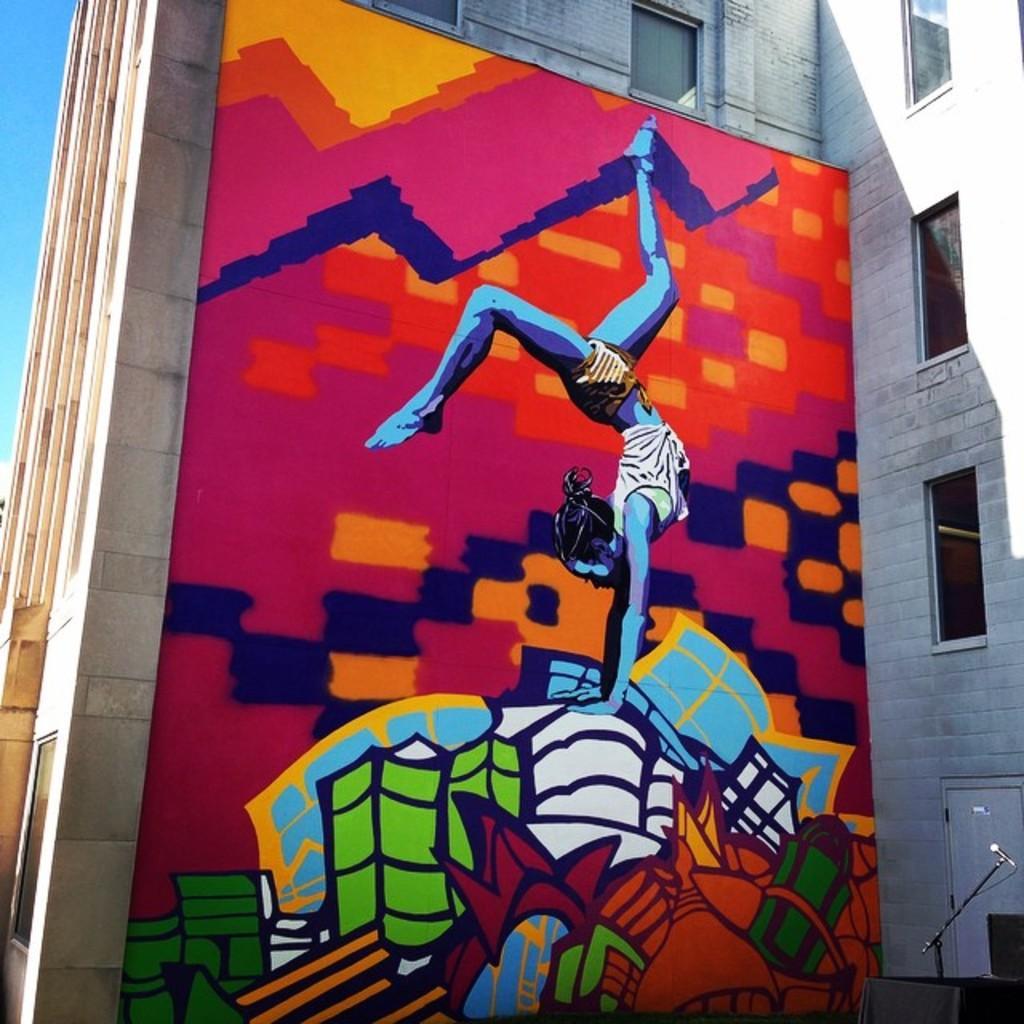Can you describe this image briefly? In the picture I can see a building and painting of a person and some other objects on the building. In the background I can see the sky. 